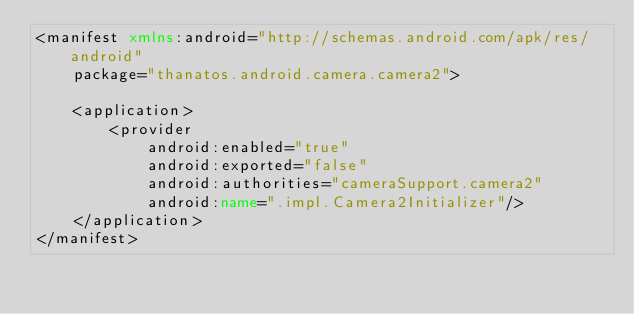Convert code to text. <code><loc_0><loc_0><loc_500><loc_500><_XML_><manifest xmlns:android="http://schemas.android.com/apk/res/android"
    package="thanatos.android.camera.camera2">

    <application>
        <provider
            android:enabled="true"
            android:exported="false"
            android:authorities="cameraSupport.camera2"
            android:name=".impl.Camera2Initializer"/>
    </application>
</manifest>
</code> 